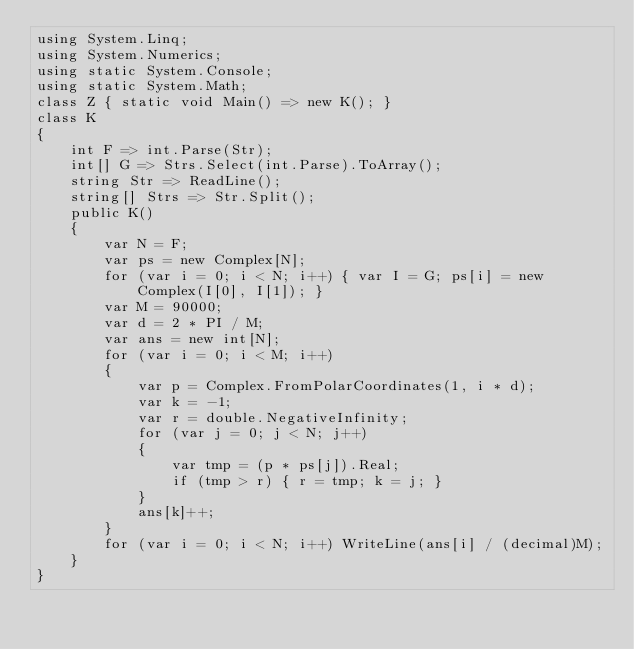<code> <loc_0><loc_0><loc_500><loc_500><_C#_>using System.Linq;
using System.Numerics;
using static System.Console;
using static System.Math;
class Z { static void Main() => new K(); }
class K
{
	int F => int.Parse(Str);
	int[] G => Strs.Select(int.Parse).ToArray();
	string Str => ReadLine();
	string[] Strs => Str.Split();
	public K()
	{
		var N = F;
		var ps = new Complex[N];
		for (var i = 0; i < N; i++) { var I = G; ps[i] = new Complex(I[0], I[1]); }
		var M = 90000;
		var d = 2 * PI / M;
		var ans = new int[N];
		for (var i = 0; i < M; i++)
		{
			var p = Complex.FromPolarCoordinates(1, i * d);
			var k = -1;
			var r = double.NegativeInfinity;
			for (var j = 0; j < N; j++)
			{
				var tmp = (p * ps[j]).Real;
				if (tmp > r) { r = tmp; k = j; }
			}
			ans[k]++;
		}
		for (var i = 0; i < N; i++) WriteLine(ans[i] / (decimal)M);
	}
}
</code> 